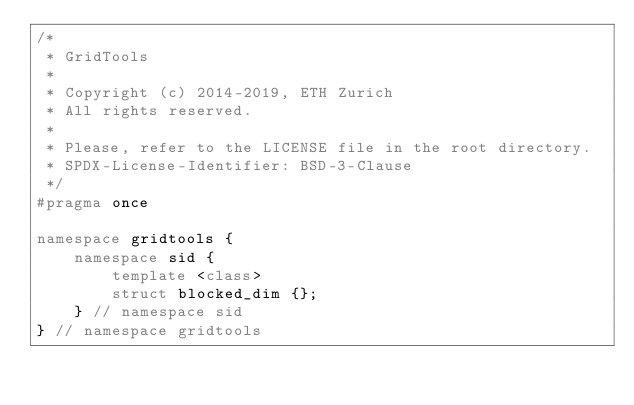<code> <loc_0><loc_0><loc_500><loc_500><_C++_>/*
 * GridTools
 *
 * Copyright (c) 2014-2019, ETH Zurich
 * All rights reserved.
 *
 * Please, refer to the LICENSE file in the root directory.
 * SPDX-License-Identifier: BSD-3-Clause
 */
#pragma once

namespace gridtools {
    namespace sid {
        template <class>
        struct blocked_dim {};
    } // namespace sid
} // namespace gridtools
</code> 